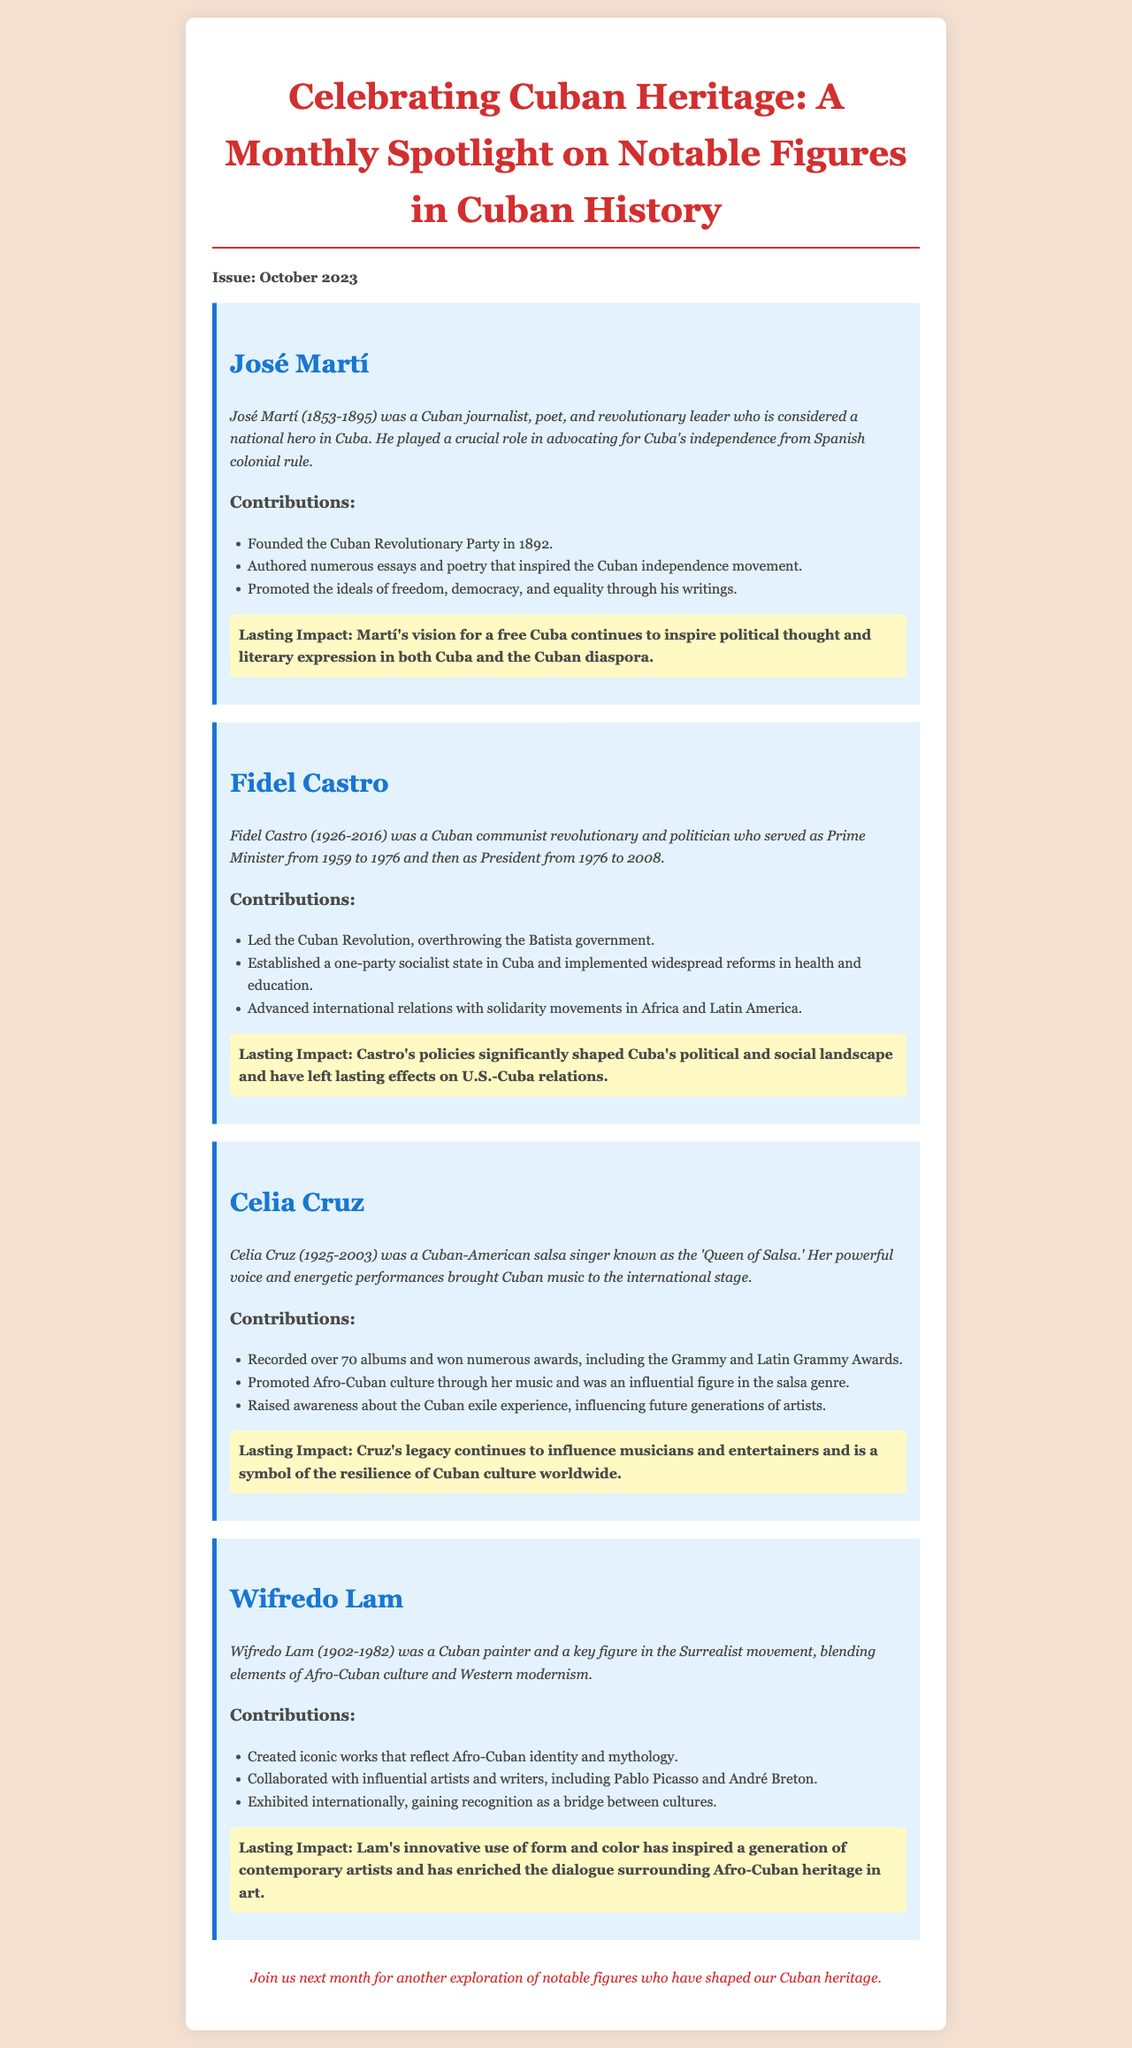What is the issue date of the newsletter? The issue date is clearly stated at the beginning of the document.
Answer: October 2023 Who is considered the 'Queen of Salsa'? The document specifically mentions a notable figure with this title.
Answer: Celia Cruz What year was José Martí born? The biography of José Martí includes his birth year.
Answer: 1853 How many albums did Celia Cruz record? The contributions section for Celia Cruz indicates this detail.
Answer: Over 70 albums What cultural movement was Wifredo Lam associated with? The biography provides information on Lam's artistic connections.
Answer: Surrealist movement What was Fidel Castro's role from 1959 to 1976? The document describes Castro's political position during this time.
Answer: Prime Minister What ideals did José Martí promote through his writings? The contributions section elaborates on Martí's advocacy.
Answer: Freedom, democracy, and equality What impact did Castro's policies have? The document states a significant effect of Castro's actions on a particular relationship.
Answer: U.S.-Cuba relations How did Celia Cruz raise awareness about Cuban culture? The contributions section for Cruz explains her influence and actions.
Answer: By promoting Afro-Cuban culture through her music 